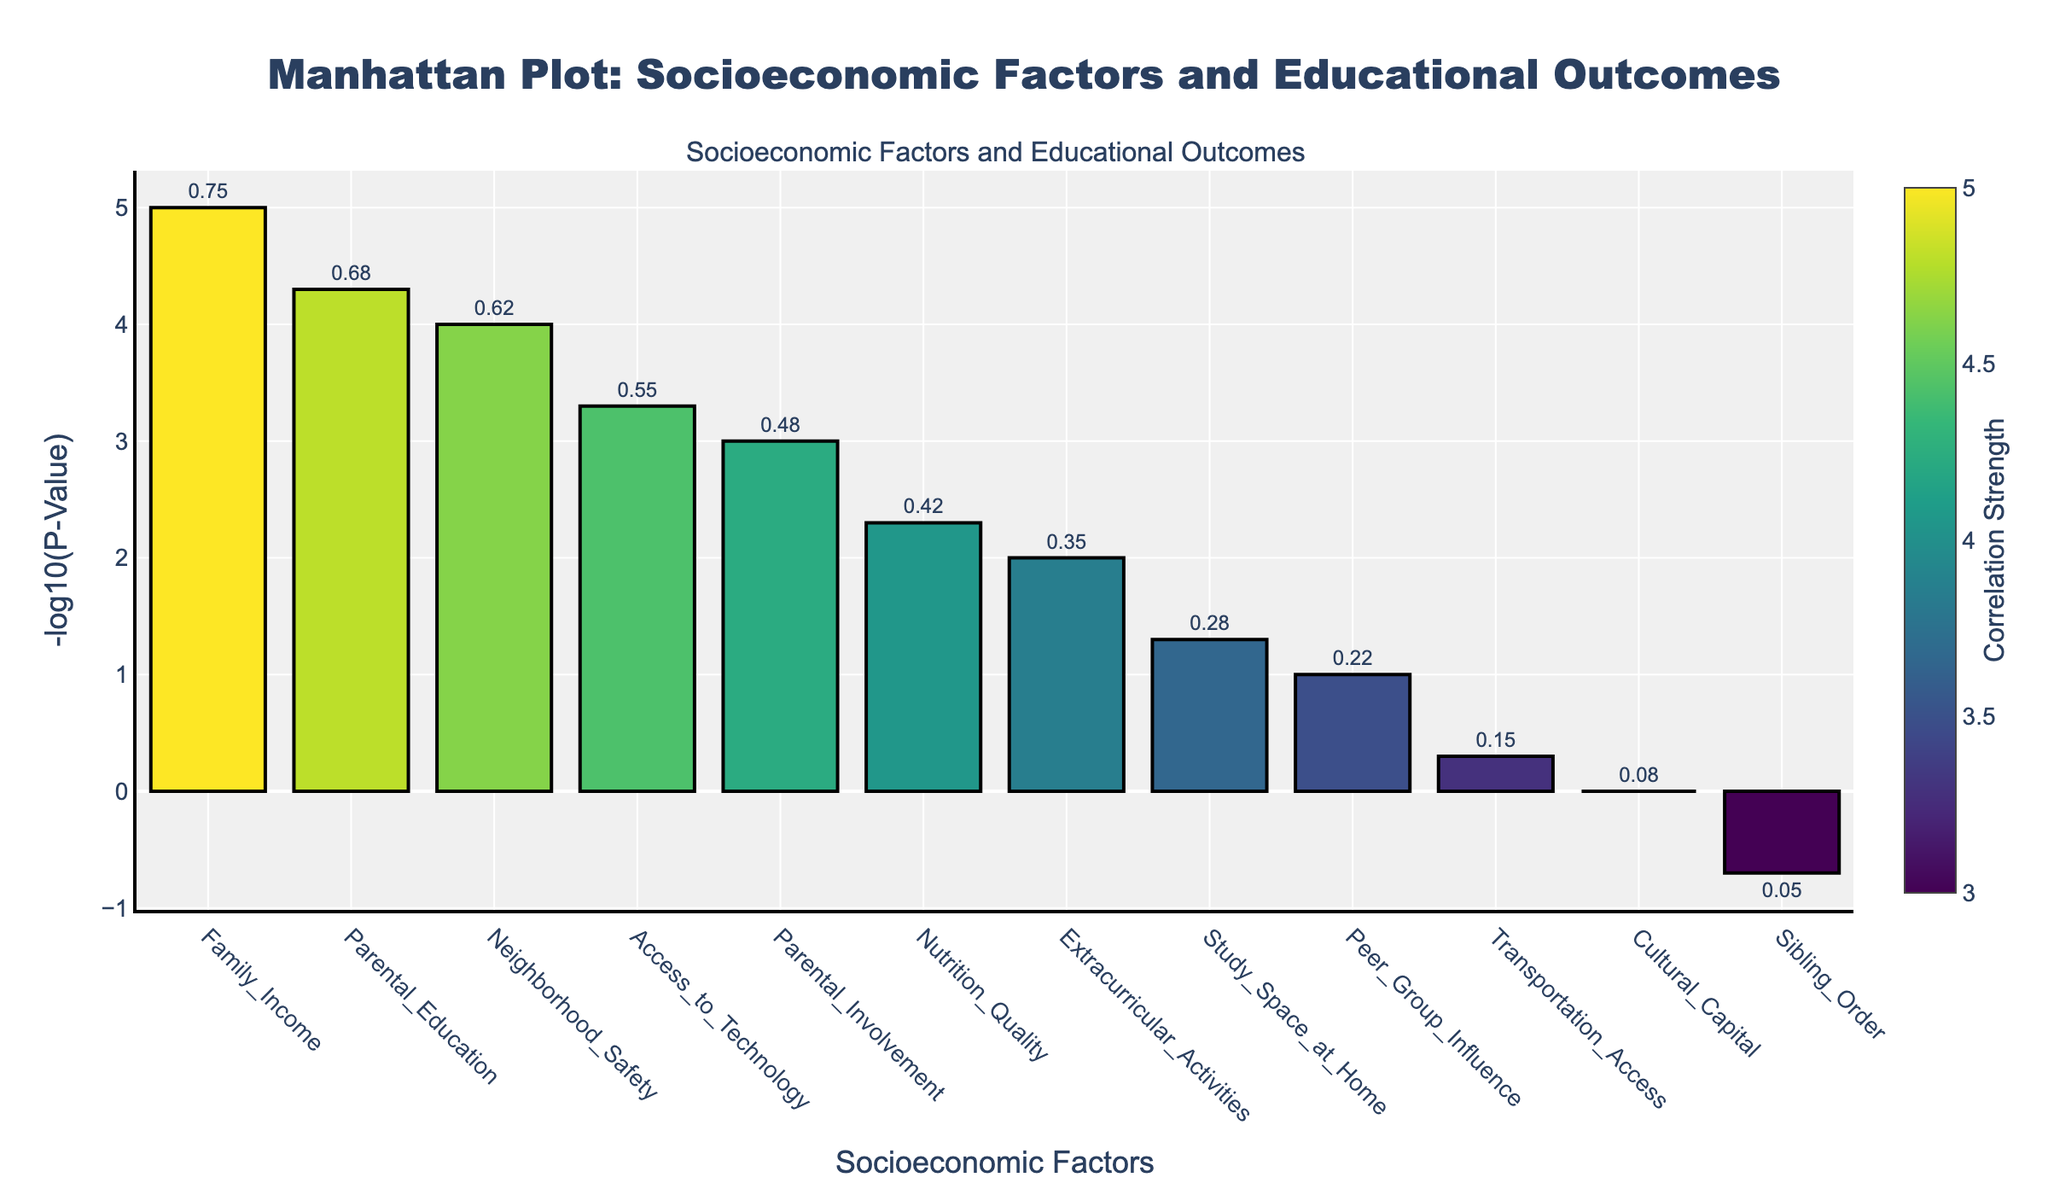What is the main title of the plot? The main title of the plot is usually located at the top of the figure. In this case, it reads "Manhattan Plot: Socioeconomic Factors and Educational Outcomes".
Answer: Manhattan Plot: Socioeconomic Factors and Educational Outcomes How many socioeconomic factors are displayed? By counting the bars on the x-axis labeled with different socioeconomic factors, you can determine the number of factors displayed. Here, there are labels for 12 different factors.
Answer: 12 Which socioeconomic factor has the lowest P-value? By looking at the heights of the bars and identifying the tallest bar (since the plot shows -log10(P-Value)), we can determine that "Family_Income" has the lowest P-value.
Answer: Family_Income What is the P-value for Parental Education? Hovering over or looking at the bar for "Parental_Education" will show the P-value as 0.00005.
Answer: 0.00005 Which factor has the highest correlation strength? The color intensity in the Viridis color scale indicates the strength of correlation. "Family_Income" has the most intense coloration, representing the highest correlation strength of 0.75.
Answer: Family_Income Compare the correlation strength for Access to Technology and Extracurricular Activities. By looking at the hover text or the color shading, "Access_to_Technology" has a strength of 0.55, and "Extracurricular_Activities" has a strength of 0.35. Thus, "Access_to_Technology" has a higher correlation strength.
Answer: Access_to_Technology Which factor has the weakest correlation strength? The factor with the weakest correlation strength will have the least intense color. "Sibling_Order" has the weakest correlation strength of 0.05.
Answer: Sibling_Order Calculate the average correlation strength of the first three factors with the strongest correlations. The first three factors are Family_Income (0.75), Parental_Education (0.68), and Neighborhood_Safety (0.62). The average correlation strength = (0.75 + 0.68 + 0.62) / 3 = 2.05 / 3 ≈ 0.68.
Answer: 0.68 What is the -log10(P-Value) for Nutrition Quality? Locate the corresponding bar for "Nutrition_Quality" and identify its height. The P-value is 0.005, so -log10(0.005) = 2.3.
Answer: 2.3 List the factors with a P-value less than 0.001. Factors with a P-value less than 0.001 can be identified by the height of the bars greater than -log10(0.001). These factors are Family_Income, Parental_Education, and Neighborhood_Safety.
Answer: Family_Income, Parental_Education, Neighborhood_Safety 